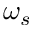Convert formula to latex. <formula><loc_0><loc_0><loc_500><loc_500>\omega _ { s }</formula> 